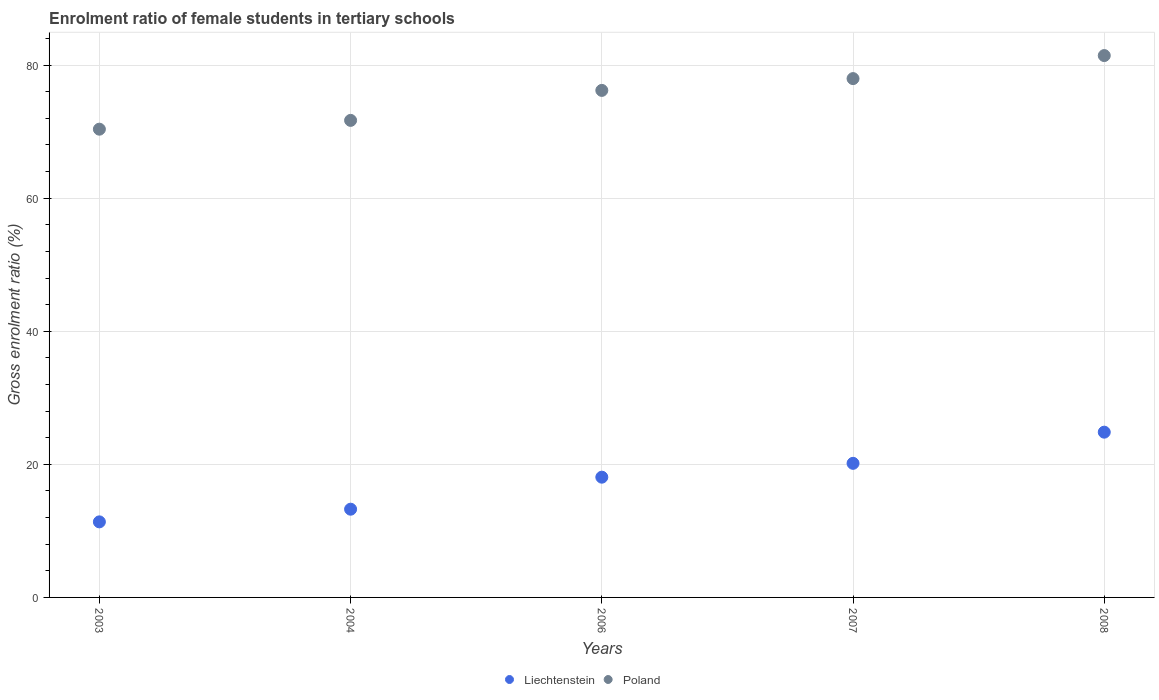Is the number of dotlines equal to the number of legend labels?
Make the answer very short. Yes. What is the enrolment ratio of female students in tertiary schools in Poland in 2006?
Your answer should be very brief. 76.2. Across all years, what is the maximum enrolment ratio of female students in tertiary schools in Poland?
Your response must be concise. 81.43. Across all years, what is the minimum enrolment ratio of female students in tertiary schools in Liechtenstein?
Ensure brevity in your answer.  11.35. In which year was the enrolment ratio of female students in tertiary schools in Poland minimum?
Offer a very short reply. 2003. What is the total enrolment ratio of female students in tertiary schools in Poland in the graph?
Your answer should be compact. 377.65. What is the difference between the enrolment ratio of female students in tertiary schools in Liechtenstein in 2004 and that in 2006?
Your answer should be very brief. -4.81. What is the difference between the enrolment ratio of female students in tertiary schools in Liechtenstein in 2003 and the enrolment ratio of female students in tertiary schools in Poland in 2008?
Offer a very short reply. -70.08. What is the average enrolment ratio of female students in tertiary schools in Liechtenstein per year?
Provide a succinct answer. 17.53. In the year 2008, what is the difference between the enrolment ratio of female students in tertiary schools in Liechtenstein and enrolment ratio of female students in tertiary schools in Poland?
Your response must be concise. -56.6. What is the ratio of the enrolment ratio of female students in tertiary schools in Liechtenstein in 2003 to that in 2008?
Keep it short and to the point. 0.46. Is the difference between the enrolment ratio of female students in tertiary schools in Liechtenstein in 2006 and 2007 greater than the difference between the enrolment ratio of female students in tertiary schools in Poland in 2006 and 2007?
Ensure brevity in your answer.  No. What is the difference between the highest and the second highest enrolment ratio of female students in tertiary schools in Poland?
Offer a terse response. 3.46. What is the difference between the highest and the lowest enrolment ratio of female students in tertiary schools in Poland?
Your answer should be very brief. 11.06. Is the sum of the enrolment ratio of female students in tertiary schools in Poland in 2004 and 2007 greater than the maximum enrolment ratio of female students in tertiary schools in Liechtenstein across all years?
Your answer should be compact. Yes. Is the enrolment ratio of female students in tertiary schools in Poland strictly greater than the enrolment ratio of female students in tertiary schools in Liechtenstein over the years?
Offer a terse response. Yes. How many dotlines are there?
Your answer should be very brief. 2. What is the difference between two consecutive major ticks on the Y-axis?
Offer a terse response. 20. Does the graph contain any zero values?
Provide a short and direct response. No. What is the title of the graph?
Offer a very short reply. Enrolment ratio of female students in tertiary schools. What is the label or title of the X-axis?
Give a very brief answer. Years. What is the Gross enrolment ratio (%) of Liechtenstein in 2003?
Offer a very short reply. 11.35. What is the Gross enrolment ratio (%) of Poland in 2003?
Your response must be concise. 70.37. What is the Gross enrolment ratio (%) in Liechtenstein in 2004?
Ensure brevity in your answer.  13.26. What is the Gross enrolment ratio (%) of Poland in 2004?
Your answer should be very brief. 71.69. What is the Gross enrolment ratio (%) in Liechtenstein in 2006?
Make the answer very short. 18.07. What is the Gross enrolment ratio (%) in Poland in 2006?
Give a very brief answer. 76.2. What is the Gross enrolment ratio (%) of Liechtenstein in 2007?
Provide a succinct answer. 20.15. What is the Gross enrolment ratio (%) of Poland in 2007?
Your answer should be very brief. 77.97. What is the Gross enrolment ratio (%) in Liechtenstein in 2008?
Provide a short and direct response. 24.84. What is the Gross enrolment ratio (%) of Poland in 2008?
Offer a terse response. 81.43. Across all years, what is the maximum Gross enrolment ratio (%) in Liechtenstein?
Keep it short and to the point. 24.84. Across all years, what is the maximum Gross enrolment ratio (%) in Poland?
Make the answer very short. 81.43. Across all years, what is the minimum Gross enrolment ratio (%) in Liechtenstein?
Your answer should be very brief. 11.35. Across all years, what is the minimum Gross enrolment ratio (%) of Poland?
Your answer should be compact. 70.37. What is the total Gross enrolment ratio (%) of Liechtenstein in the graph?
Offer a very short reply. 87.67. What is the total Gross enrolment ratio (%) in Poland in the graph?
Provide a short and direct response. 377.65. What is the difference between the Gross enrolment ratio (%) in Liechtenstein in 2003 and that in 2004?
Make the answer very short. -1.9. What is the difference between the Gross enrolment ratio (%) in Poland in 2003 and that in 2004?
Provide a short and direct response. -1.32. What is the difference between the Gross enrolment ratio (%) of Liechtenstein in 2003 and that in 2006?
Ensure brevity in your answer.  -6.72. What is the difference between the Gross enrolment ratio (%) in Poland in 2003 and that in 2006?
Make the answer very short. -5.83. What is the difference between the Gross enrolment ratio (%) of Liechtenstein in 2003 and that in 2007?
Your response must be concise. -8.8. What is the difference between the Gross enrolment ratio (%) of Poland in 2003 and that in 2007?
Provide a succinct answer. -7.6. What is the difference between the Gross enrolment ratio (%) in Liechtenstein in 2003 and that in 2008?
Provide a short and direct response. -13.48. What is the difference between the Gross enrolment ratio (%) in Poland in 2003 and that in 2008?
Offer a terse response. -11.06. What is the difference between the Gross enrolment ratio (%) of Liechtenstein in 2004 and that in 2006?
Provide a succinct answer. -4.81. What is the difference between the Gross enrolment ratio (%) in Poland in 2004 and that in 2006?
Give a very brief answer. -4.51. What is the difference between the Gross enrolment ratio (%) of Liechtenstein in 2004 and that in 2007?
Make the answer very short. -6.89. What is the difference between the Gross enrolment ratio (%) in Poland in 2004 and that in 2007?
Keep it short and to the point. -6.28. What is the difference between the Gross enrolment ratio (%) of Liechtenstein in 2004 and that in 2008?
Make the answer very short. -11.58. What is the difference between the Gross enrolment ratio (%) in Poland in 2004 and that in 2008?
Give a very brief answer. -9.74. What is the difference between the Gross enrolment ratio (%) of Liechtenstein in 2006 and that in 2007?
Provide a short and direct response. -2.08. What is the difference between the Gross enrolment ratio (%) of Poland in 2006 and that in 2007?
Offer a very short reply. -1.77. What is the difference between the Gross enrolment ratio (%) in Liechtenstein in 2006 and that in 2008?
Ensure brevity in your answer.  -6.76. What is the difference between the Gross enrolment ratio (%) in Poland in 2006 and that in 2008?
Offer a terse response. -5.24. What is the difference between the Gross enrolment ratio (%) of Liechtenstein in 2007 and that in 2008?
Keep it short and to the point. -4.68. What is the difference between the Gross enrolment ratio (%) in Poland in 2007 and that in 2008?
Provide a short and direct response. -3.46. What is the difference between the Gross enrolment ratio (%) in Liechtenstein in 2003 and the Gross enrolment ratio (%) in Poland in 2004?
Keep it short and to the point. -60.33. What is the difference between the Gross enrolment ratio (%) in Liechtenstein in 2003 and the Gross enrolment ratio (%) in Poland in 2006?
Offer a very short reply. -64.84. What is the difference between the Gross enrolment ratio (%) in Liechtenstein in 2003 and the Gross enrolment ratio (%) in Poland in 2007?
Offer a terse response. -66.61. What is the difference between the Gross enrolment ratio (%) of Liechtenstein in 2003 and the Gross enrolment ratio (%) of Poland in 2008?
Give a very brief answer. -70.08. What is the difference between the Gross enrolment ratio (%) in Liechtenstein in 2004 and the Gross enrolment ratio (%) in Poland in 2006?
Provide a succinct answer. -62.94. What is the difference between the Gross enrolment ratio (%) of Liechtenstein in 2004 and the Gross enrolment ratio (%) of Poland in 2007?
Offer a very short reply. -64.71. What is the difference between the Gross enrolment ratio (%) of Liechtenstein in 2004 and the Gross enrolment ratio (%) of Poland in 2008?
Provide a short and direct response. -68.17. What is the difference between the Gross enrolment ratio (%) of Liechtenstein in 2006 and the Gross enrolment ratio (%) of Poland in 2007?
Your answer should be compact. -59.9. What is the difference between the Gross enrolment ratio (%) in Liechtenstein in 2006 and the Gross enrolment ratio (%) in Poland in 2008?
Your answer should be compact. -63.36. What is the difference between the Gross enrolment ratio (%) of Liechtenstein in 2007 and the Gross enrolment ratio (%) of Poland in 2008?
Give a very brief answer. -61.28. What is the average Gross enrolment ratio (%) of Liechtenstein per year?
Give a very brief answer. 17.53. What is the average Gross enrolment ratio (%) of Poland per year?
Keep it short and to the point. 75.53. In the year 2003, what is the difference between the Gross enrolment ratio (%) in Liechtenstein and Gross enrolment ratio (%) in Poland?
Ensure brevity in your answer.  -59.01. In the year 2004, what is the difference between the Gross enrolment ratio (%) of Liechtenstein and Gross enrolment ratio (%) of Poland?
Make the answer very short. -58.43. In the year 2006, what is the difference between the Gross enrolment ratio (%) of Liechtenstein and Gross enrolment ratio (%) of Poland?
Provide a short and direct response. -58.12. In the year 2007, what is the difference between the Gross enrolment ratio (%) of Liechtenstein and Gross enrolment ratio (%) of Poland?
Offer a terse response. -57.82. In the year 2008, what is the difference between the Gross enrolment ratio (%) in Liechtenstein and Gross enrolment ratio (%) in Poland?
Keep it short and to the point. -56.6. What is the ratio of the Gross enrolment ratio (%) of Liechtenstein in 2003 to that in 2004?
Provide a short and direct response. 0.86. What is the ratio of the Gross enrolment ratio (%) of Poland in 2003 to that in 2004?
Keep it short and to the point. 0.98. What is the ratio of the Gross enrolment ratio (%) in Liechtenstein in 2003 to that in 2006?
Keep it short and to the point. 0.63. What is the ratio of the Gross enrolment ratio (%) of Poland in 2003 to that in 2006?
Your response must be concise. 0.92. What is the ratio of the Gross enrolment ratio (%) of Liechtenstein in 2003 to that in 2007?
Your response must be concise. 0.56. What is the ratio of the Gross enrolment ratio (%) in Poland in 2003 to that in 2007?
Give a very brief answer. 0.9. What is the ratio of the Gross enrolment ratio (%) of Liechtenstein in 2003 to that in 2008?
Offer a very short reply. 0.46. What is the ratio of the Gross enrolment ratio (%) in Poland in 2003 to that in 2008?
Ensure brevity in your answer.  0.86. What is the ratio of the Gross enrolment ratio (%) in Liechtenstein in 2004 to that in 2006?
Provide a short and direct response. 0.73. What is the ratio of the Gross enrolment ratio (%) in Poland in 2004 to that in 2006?
Keep it short and to the point. 0.94. What is the ratio of the Gross enrolment ratio (%) in Liechtenstein in 2004 to that in 2007?
Give a very brief answer. 0.66. What is the ratio of the Gross enrolment ratio (%) of Poland in 2004 to that in 2007?
Your answer should be compact. 0.92. What is the ratio of the Gross enrolment ratio (%) in Liechtenstein in 2004 to that in 2008?
Ensure brevity in your answer.  0.53. What is the ratio of the Gross enrolment ratio (%) of Poland in 2004 to that in 2008?
Offer a terse response. 0.88. What is the ratio of the Gross enrolment ratio (%) of Liechtenstein in 2006 to that in 2007?
Keep it short and to the point. 0.9. What is the ratio of the Gross enrolment ratio (%) in Poland in 2006 to that in 2007?
Make the answer very short. 0.98. What is the ratio of the Gross enrolment ratio (%) in Liechtenstein in 2006 to that in 2008?
Make the answer very short. 0.73. What is the ratio of the Gross enrolment ratio (%) of Poland in 2006 to that in 2008?
Offer a very short reply. 0.94. What is the ratio of the Gross enrolment ratio (%) of Liechtenstein in 2007 to that in 2008?
Offer a very short reply. 0.81. What is the ratio of the Gross enrolment ratio (%) of Poland in 2007 to that in 2008?
Keep it short and to the point. 0.96. What is the difference between the highest and the second highest Gross enrolment ratio (%) of Liechtenstein?
Make the answer very short. 4.68. What is the difference between the highest and the second highest Gross enrolment ratio (%) in Poland?
Your answer should be compact. 3.46. What is the difference between the highest and the lowest Gross enrolment ratio (%) in Liechtenstein?
Your response must be concise. 13.48. What is the difference between the highest and the lowest Gross enrolment ratio (%) of Poland?
Make the answer very short. 11.06. 